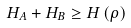<formula> <loc_0><loc_0><loc_500><loc_500>H _ { A } + H _ { B } \geq H \left ( \rho \right )</formula> 